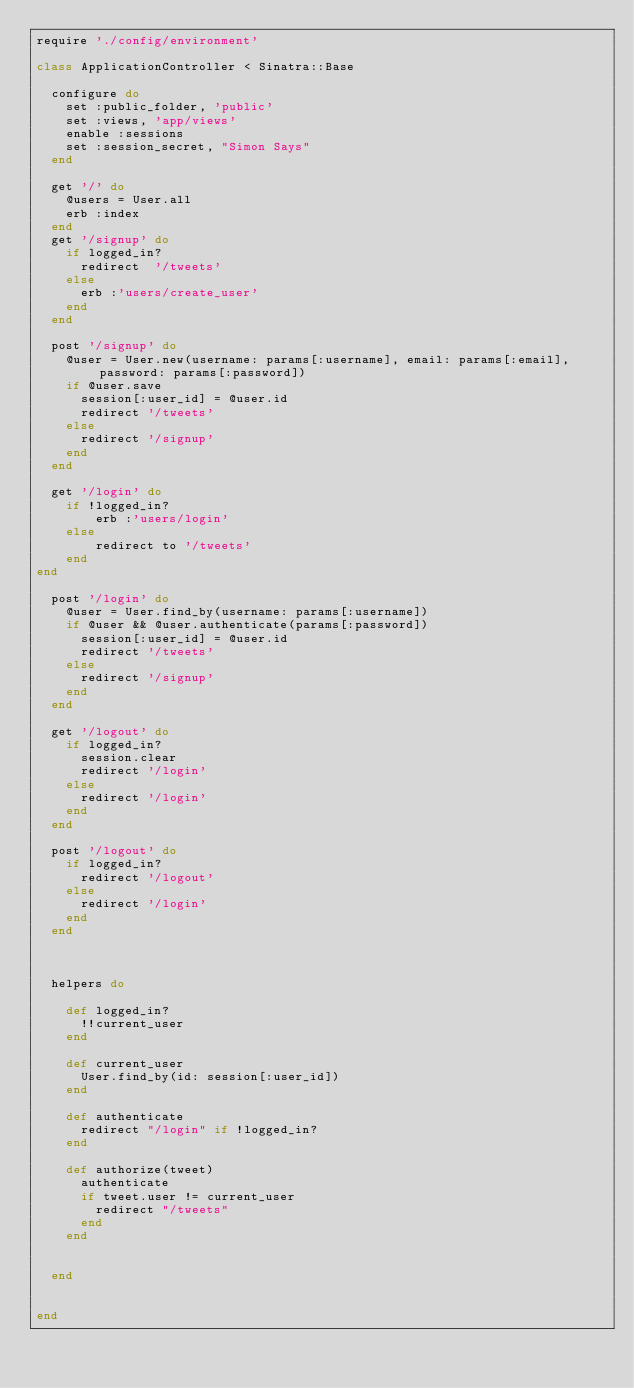<code> <loc_0><loc_0><loc_500><loc_500><_Ruby_>require './config/environment'

class ApplicationController < Sinatra::Base

  configure do
    set :public_folder, 'public'
    set :views, 'app/views'
    enable :sessions 
    set :session_secret, "Simon Says"
  end

  get '/' do 
    @users = User.all
    erb :index
  end 
  get '/signup' do
    if logged_in?
      redirect  '/tweets'
    else
      erb :'users/create_user'
    end 
  end

  post '/signup' do
    @user = User.new(username: params[:username], email: params[:email], password: params[:password])
    if @user.save
      session[:user_id] = @user.id 
      redirect '/tweets'
    else
      redirect '/signup'
    end 
  end 

  get '/login' do
    if !logged_in?
        erb :'users/login'
    else
        redirect to '/tweets'
    end
end

  post '/login' do 
    @user = User.find_by(username: params[:username])
    if @user && @user.authenticate(params[:password])
      session[:user_id] = @user.id
      redirect '/tweets'
    else 
      redirect '/signup'
    end   
  end 

  get '/logout' do 
    if logged_in?
      session.clear
      redirect '/login'
    else 
      redirect '/login'
    end 
  end 

  post '/logout' do 
    if logged_in?
      redirect '/logout'
    else 
      redirect '/login'
    end 
  end 



  helpers do 

    def logged_in?
      !!current_user
    end 

    def current_user
      User.find_by(id: session[:user_id])
    end 

    def authenticate 
      redirect "/login" if !logged_in?
    end 

    def authorize(tweet)
      authenticate
      if tweet.user != current_user 
        redirect "/tweets"
      end 
    end


  end 


end
</code> 